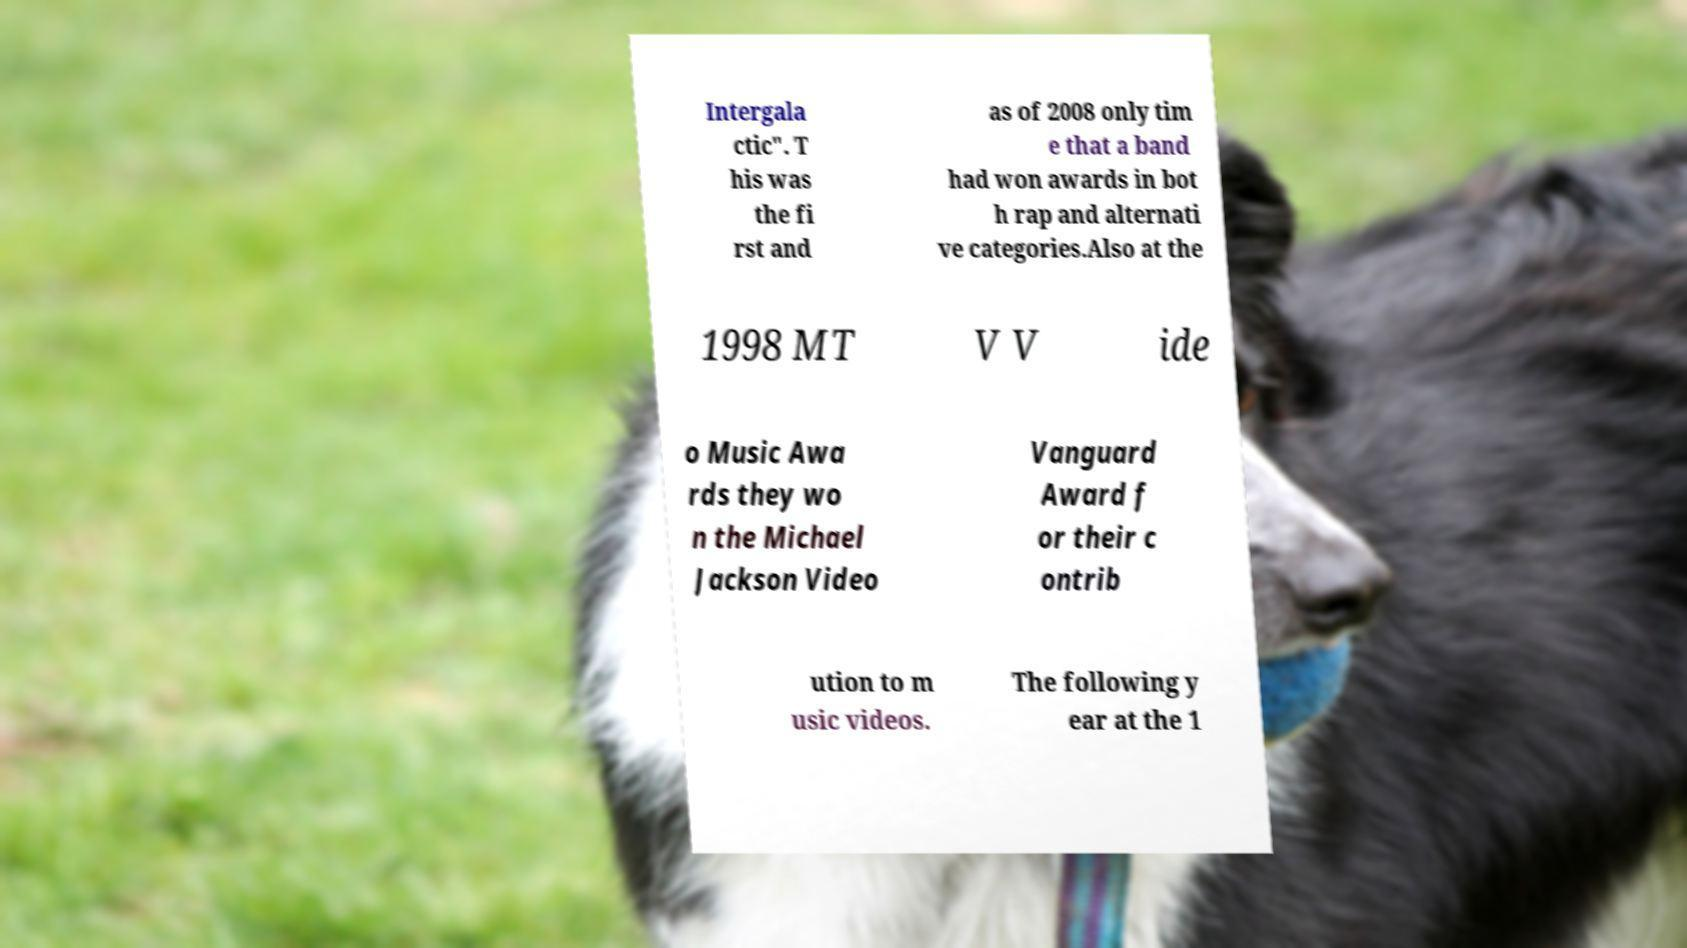Can you accurately transcribe the text from the provided image for me? Intergala ctic". T his was the fi rst and as of 2008 only tim e that a band had won awards in bot h rap and alternati ve categories.Also at the 1998 MT V V ide o Music Awa rds they wo n the Michael Jackson Video Vanguard Award f or their c ontrib ution to m usic videos. The following y ear at the 1 